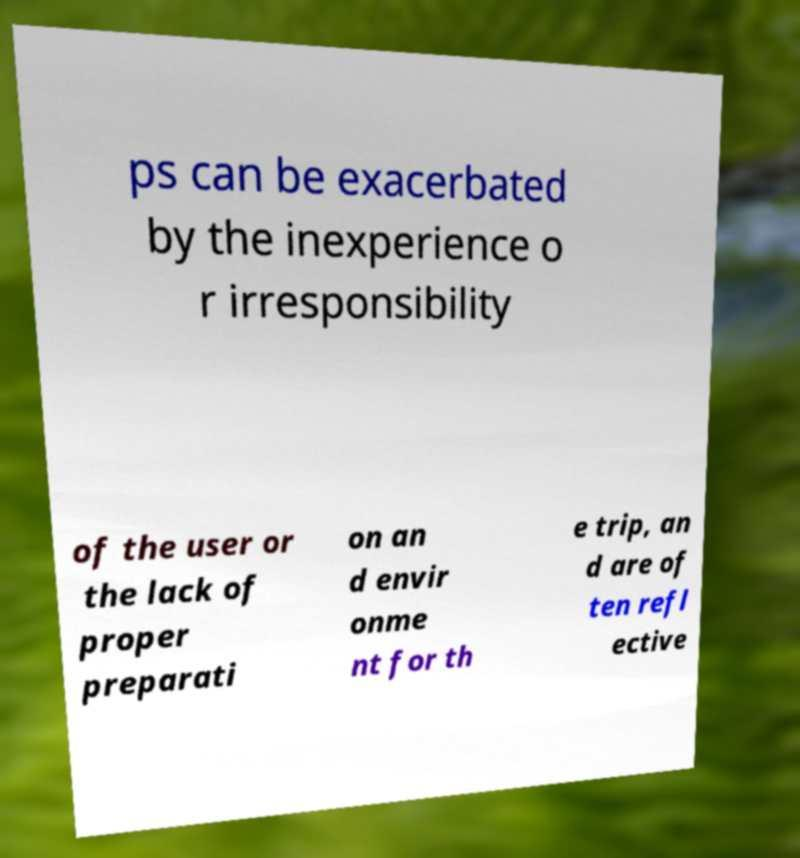What messages or text are displayed in this image? I need them in a readable, typed format. ps can be exacerbated by the inexperience o r irresponsibility of the user or the lack of proper preparati on an d envir onme nt for th e trip, an d are of ten refl ective 